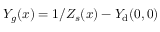<formula> <loc_0><loc_0><loc_500><loc_500>Y _ { g } ( x ) = 1 / Z _ { s } ( x ) - { Y } _ { d } ( 0 , 0 )</formula> 